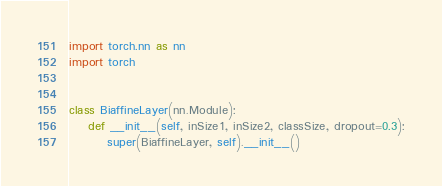<code> <loc_0><loc_0><loc_500><loc_500><_Python_>import torch.nn as nn
import torch


class BiaffineLayer(nn.Module):
    def __init__(self, inSize1, inSize2, classSize, dropout=0.3):
        super(BiaffineLayer, self).__init__()
</code> 